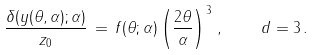<formula> <loc_0><loc_0><loc_500><loc_500>\frac { \delta ( y ( \theta , \alpha ) ; \alpha ) } { z _ { 0 } } \, = \, f ( \theta ; \alpha ) \left ( \frac { 2 \theta } { \alpha } \right ) ^ { 3 } \, , \quad d = 3 \, .</formula> 